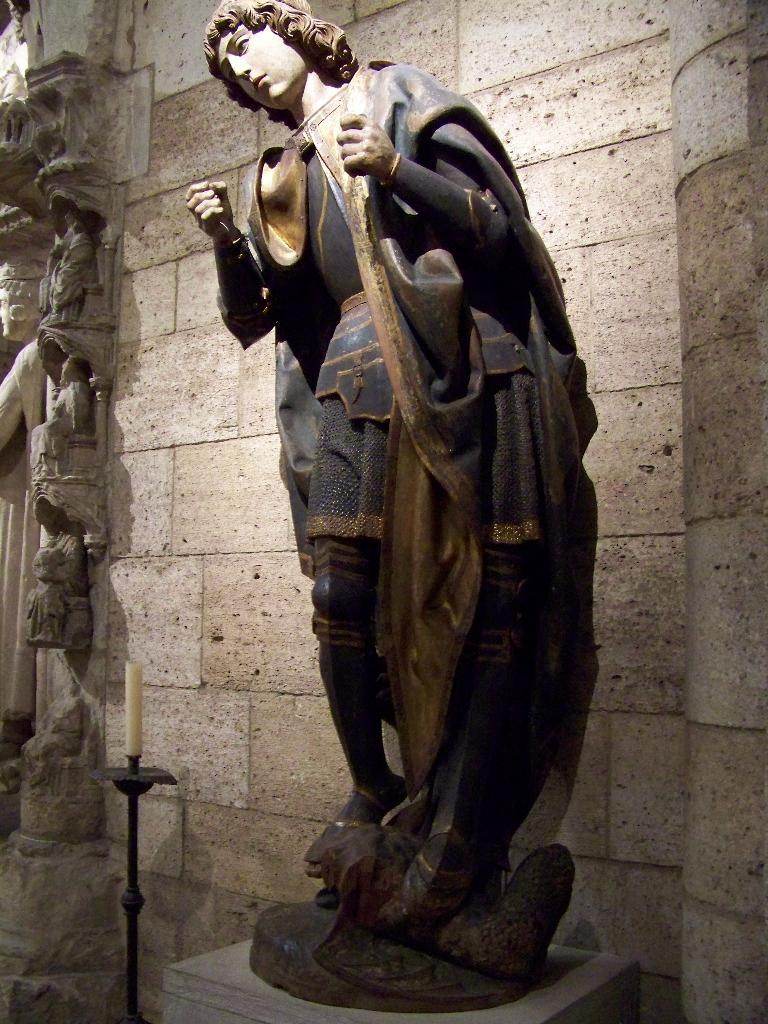What is the main subject on the platform in the image? There is a sculpture on a platform in the image. What is placed near the sculpture? There is a candle with a stand near the sculpture. What can be seen behind the sculpture? There is a wall behind the sculpture, and statues are visible behind it. What type of flower is being used to provide comfort to the committee in the image? There is no flower or committee present in the image. 